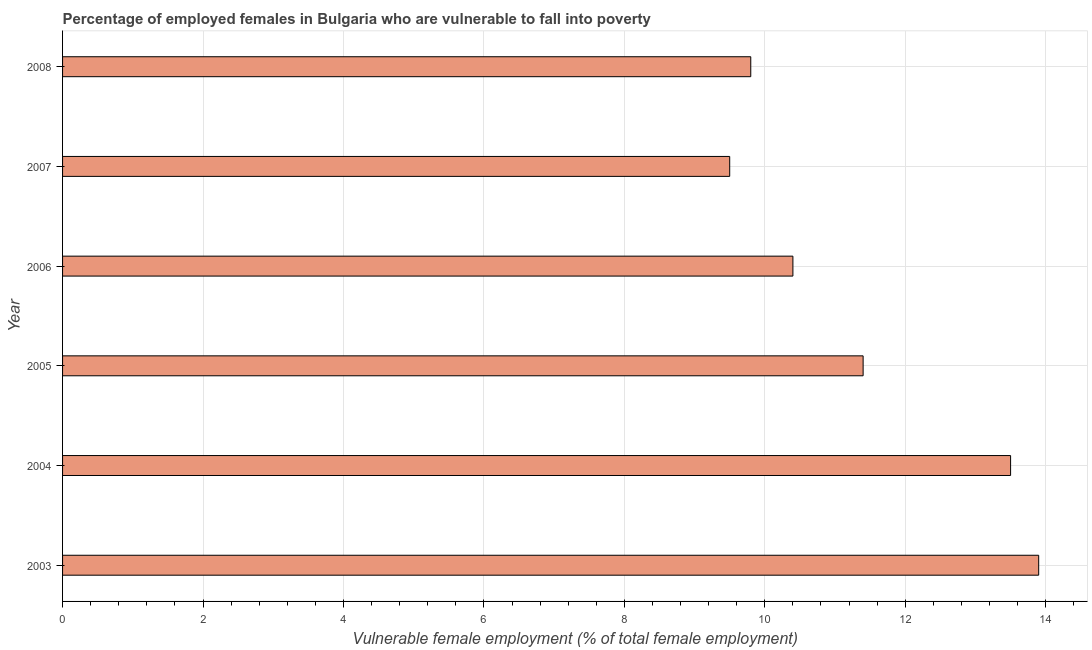Does the graph contain any zero values?
Your answer should be compact. No. Does the graph contain grids?
Provide a short and direct response. Yes. What is the title of the graph?
Keep it short and to the point. Percentage of employed females in Bulgaria who are vulnerable to fall into poverty. What is the label or title of the X-axis?
Offer a terse response. Vulnerable female employment (% of total female employment). What is the label or title of the Y-axis?
Provide a succinct answer. Year. What is the percentage of employed females who are vulnerable to fall into poverty in 2004?
Provide a short and direct response. 13.5. Across all years, what is the maximum percentage of employed females who are vulnerable to fall into poverty?
Offer a very short reply. 13.9. What is the sum of the percentage of employed females who are vulnerable to fall into poverty?
Your answer should be compact. 68.5. What is the average percentage of employed females who are vulnerable to fall into poverty per year?
Ensure brevity in your answer.  11.42. What is the median percentage of employed females who are vulnerable to fall into poverty?
Your answer should be compact. 10.9. In how many years, is the percentage of employed females who are vulnerable to fall into poverty greater than 2.8 %?
Your answer should be compact. 6. Do a majority of the years between 2007 and 2004 (inclusive) have percentage of employed females who are vulnerable to fall into poverty greater than 12.4 %?
Provide a succinct answer. Yes. What is the ratio of the percentage of employed females who are vulnerable to fall into poverty in 2006 to that in 2007?
Keep it short and to the point. 1.09. What is the difference between the highest and the second highest percentage of employed females who are vulnerable to fall into poverty?
Your response must be concise. 0.4. How many bars are there?
Your response must be concise. 6. What is the difference between two consecutive major ticks on the X-axis?
Make the answer very short. 2. Are the values on the major ticks of X-axis written in scientific E-notation?
Give a very brief answer. No. What is the Vulnerable female employment (% of total female employment) of 2003?
Your answer should be very brief. 13.9. What is the Vulnerable female employment (% of total female employment) of 2005?
Your response must be concise. 11.4. What is the Vulnerable female employment (% of total female employment) of 2006?
Give a very brief answer. 10.4. What is the Vulnerable female employment (% of total female employment) of 2007?
Provide a short and direct response. 9.5. What is the Vulnerable female employment (% of total female employment) of 2008?
Provide a short and direct response. 9.8. What is the difference between the Vulnerable female employment (% of total female employment) in 2003 and 2008?
Provide a short and direct response. 4.1. What is the difference between the Vulnerable female employment (% of total female employment) in 2004 and 2005?
Ensure brevity in your answer.  2.1. What is the difference between the Vulnerable female employment (% of total female employment) in 2004 and 2007?
Provide a succinct answer. 4. What is the difference between the Vulnerable female employment (% of total female employment) in 2005 and 2006?
Ensure brevity in your answer.  1. What is the difference between the Vulnerable female employment (% of total female employment) in 2005 and 2008?
Make the answer very short. 1.6. What is the difference between the Vulnerable female employment (% of total female employment) in 2006 and 2007?
Your answer should be compact. 0.9. What is the difference between the Vulnerable female employment (% of total female employment) in 2006 and 2008?
Provide a short and direct response. 0.6. What is the difference between the Vulnerable female employment (% of total female employment) in 2007 and 2008?
Keep it short and to the point. -0.3. What is the ratio of the Vulnerable female employment (% of total female employment) in 2003 to that in 2005?
Offer a very short reply. 1.22. What is the ratio of the Vulnerable female employment (% of total female employment) in 2003 to that in 2006?
Provide a short and direct response. 1.34. What is the ratio of the Vulnerable female employment (% of total female employment) in 2003 to that in 2007?
Provide a short and direct response. 1.46. What is the ratio of the Vulnerable female employment (% of total female employment) in 2003 to that in 2008?
Keep it short and to the point. 1.42. What is the ratio of the Vulnerable female employment (% of total female employment) in 2004 to that in 2005?
Keep it short and to the point. 1.18. What is the ratio of the Vulnerable female employment (% of total female employment) in 2004 to that in 2006?
Your answer should be compact. 1.3. What is the ratio of the Vulnerable female employment (% of total female employment) in 2004 to that in 2007?
Offer a very short reply. 1.42. What is the ratio of the Vulnerable female employment (% of total female employment) in 2004 to that in 2008?
Offer a terse response. 1.38. What is the ratio of the Vulnerable female employment (% of total female employment) in 2005 to that in 2006?
Give a very brief answer. 1.1. What is the ratio of the Vulnerable female employment (% of total female employment) in 2005 to that in 2007?
Your answer should be compact. 1.2. What is the ratio of the Vulnerable female employment (% of total female employment) in 2005 to that in 2008?
Give a very brief answer. 1.16. What is the ratio of the Vulnerable female employment (% of total female employment) in 2006 to that in 2007?
Your answer should be very brief. 1.09. What is the ratio of the Vulnerable female employment (% of total female employment) in 2006 to that in 2008?
Your response must be concise. 1.06. What is the ratio of the Vulnerable female employment (% of total female employment) in 2007 to that in 2008?
Provide a succinct answer. 0.97. 